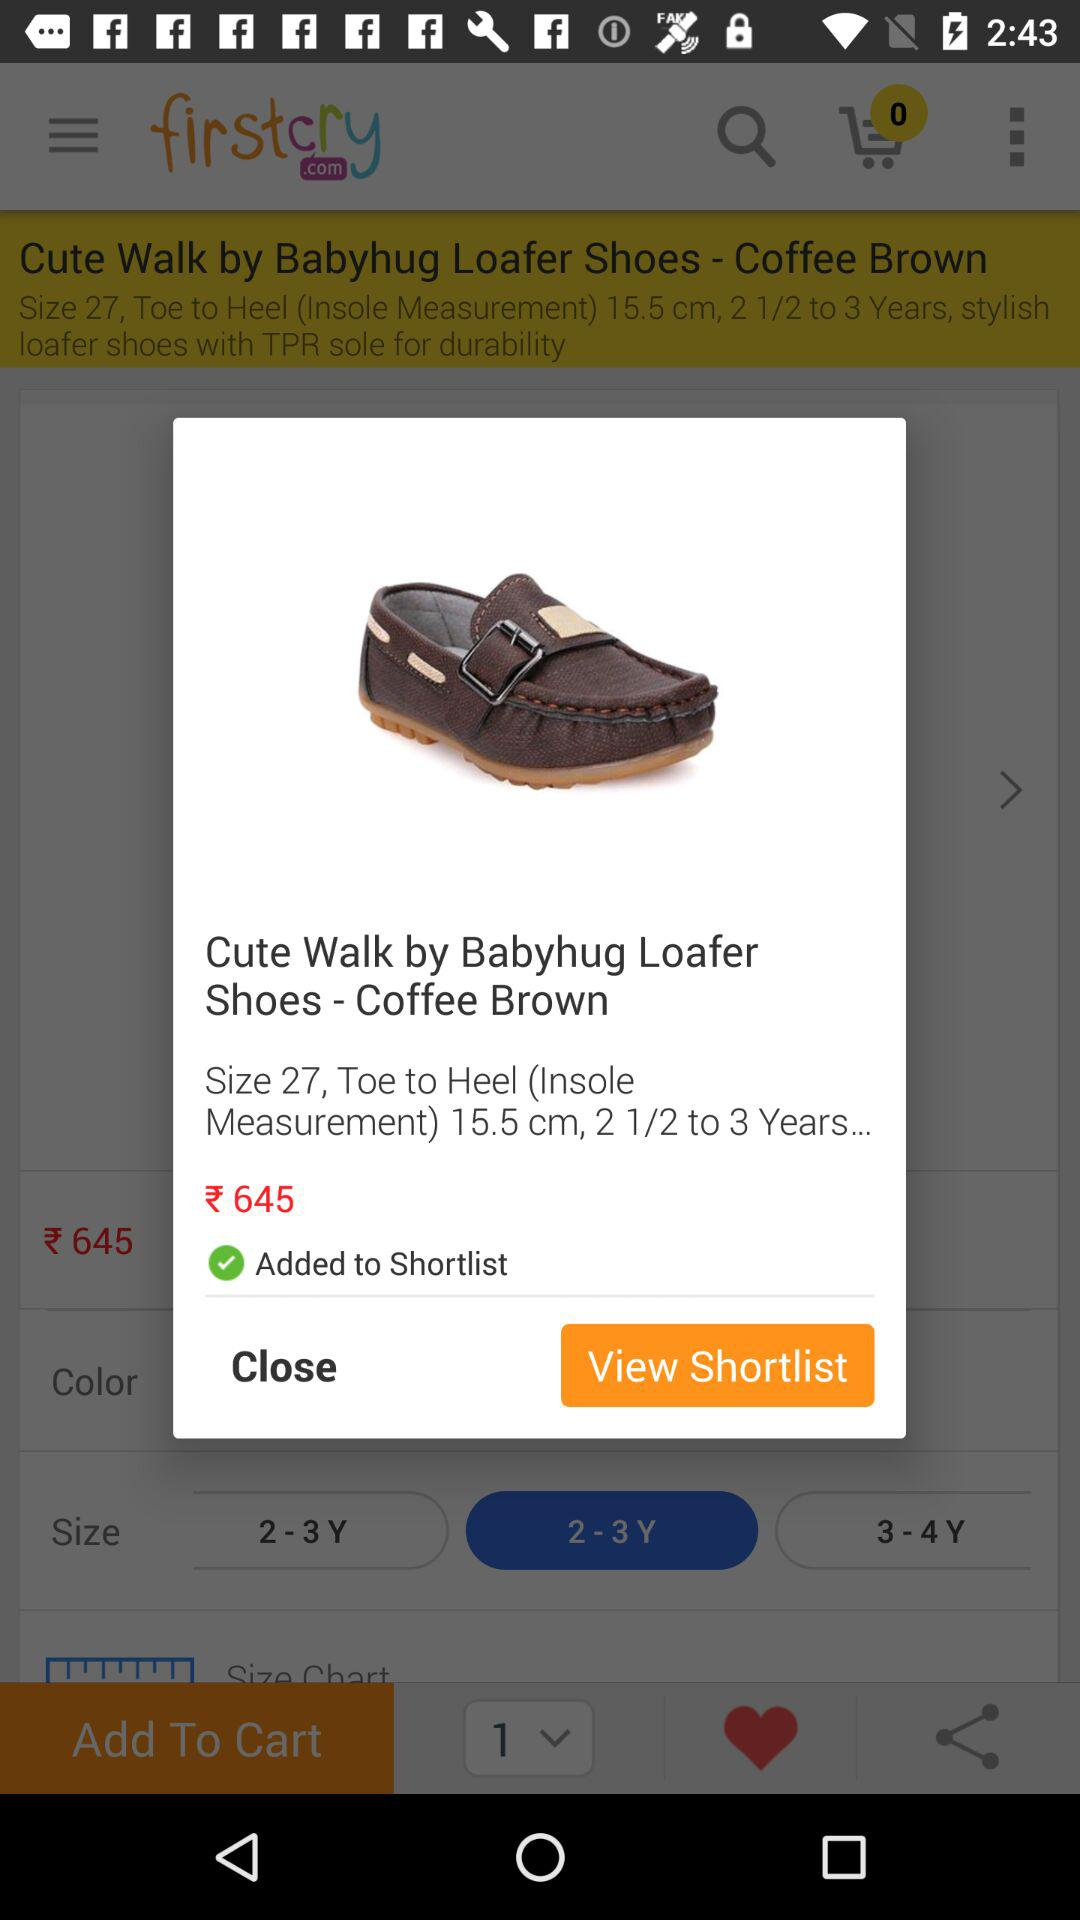What is the size of the shoes? The size of the shoes is 27. 